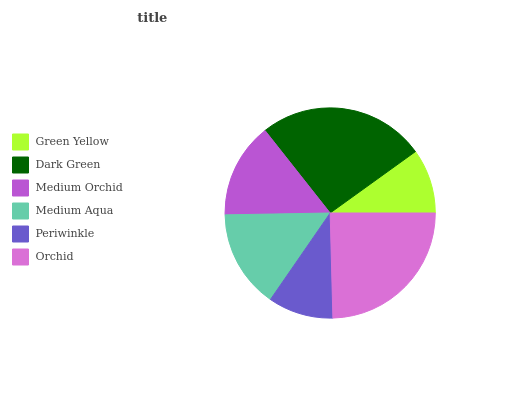Is Green Yellow the minimum?
Answer yes or no. Yes. Is Dark Green the maximum?
Answer yes or no. Yes. Is Medium Orchid the minimum?
Answer yes or no. No. Is Medium Orchid the maximum?
Answer yes or no. No. Is Dark Green greater than Medium Orchid?
Answer yes or no. Yes. Is Medium Orchid less than Dark Green?
Answer yes or no. Yes. Is Medium Orchid greater than Dark Green?
Answer yes or no. No. Is Dark Green less than Medium Orchid?
Answer yes or no. No. Is Medium Aqua the high median?
Answer yes or no. Yes. Is Medium Orchid the low median?
Answer yes or no. Yes. Is Periwinkle the high median?
Answer yes or no. No. Is Green Yellow the low median?
Answer yes or no. No. 